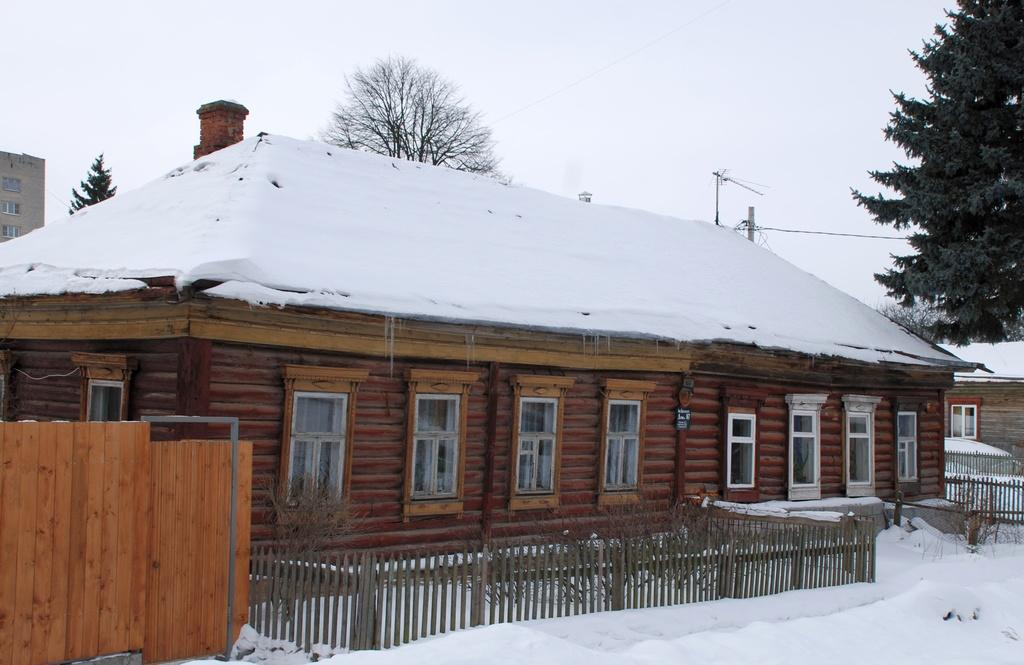What is the main feature of the landscape in the image? There is snow in the image. What can be seen near the snow? There is a railing in the image. What type of structure is visible in the image? There is a house with windows in the image. What can be seen in the distance in the image? There are many trees in the background of the image, and the sky is visible in the background as well. Can you see any horses running through the snow in the image? There are no horses present in the image; it only features snow, a railing, a house, trees, and the sky. 